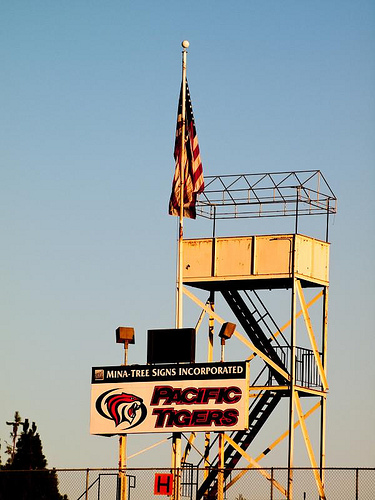<image>
Is the flagpole on the tower? Yes. Looking at the image, I can see the flagpole is positioned on top of the tower, with the tower providing support. 